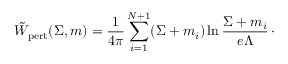Convert formula to latex. <formula><loc_0><loc_0><loc_500><loc_500>\tilde { W } _ { p e r t } ( \Sigma , m ) = { \frac { 1 } { 4 \pi } } \sum _ { i = 1 } ^ { N + 1 } ( \Sigma + m _ { i } ) \ln { \frac { \Sigma + m _ { i } } { e \Lambda } } \, \cdot</formula> 